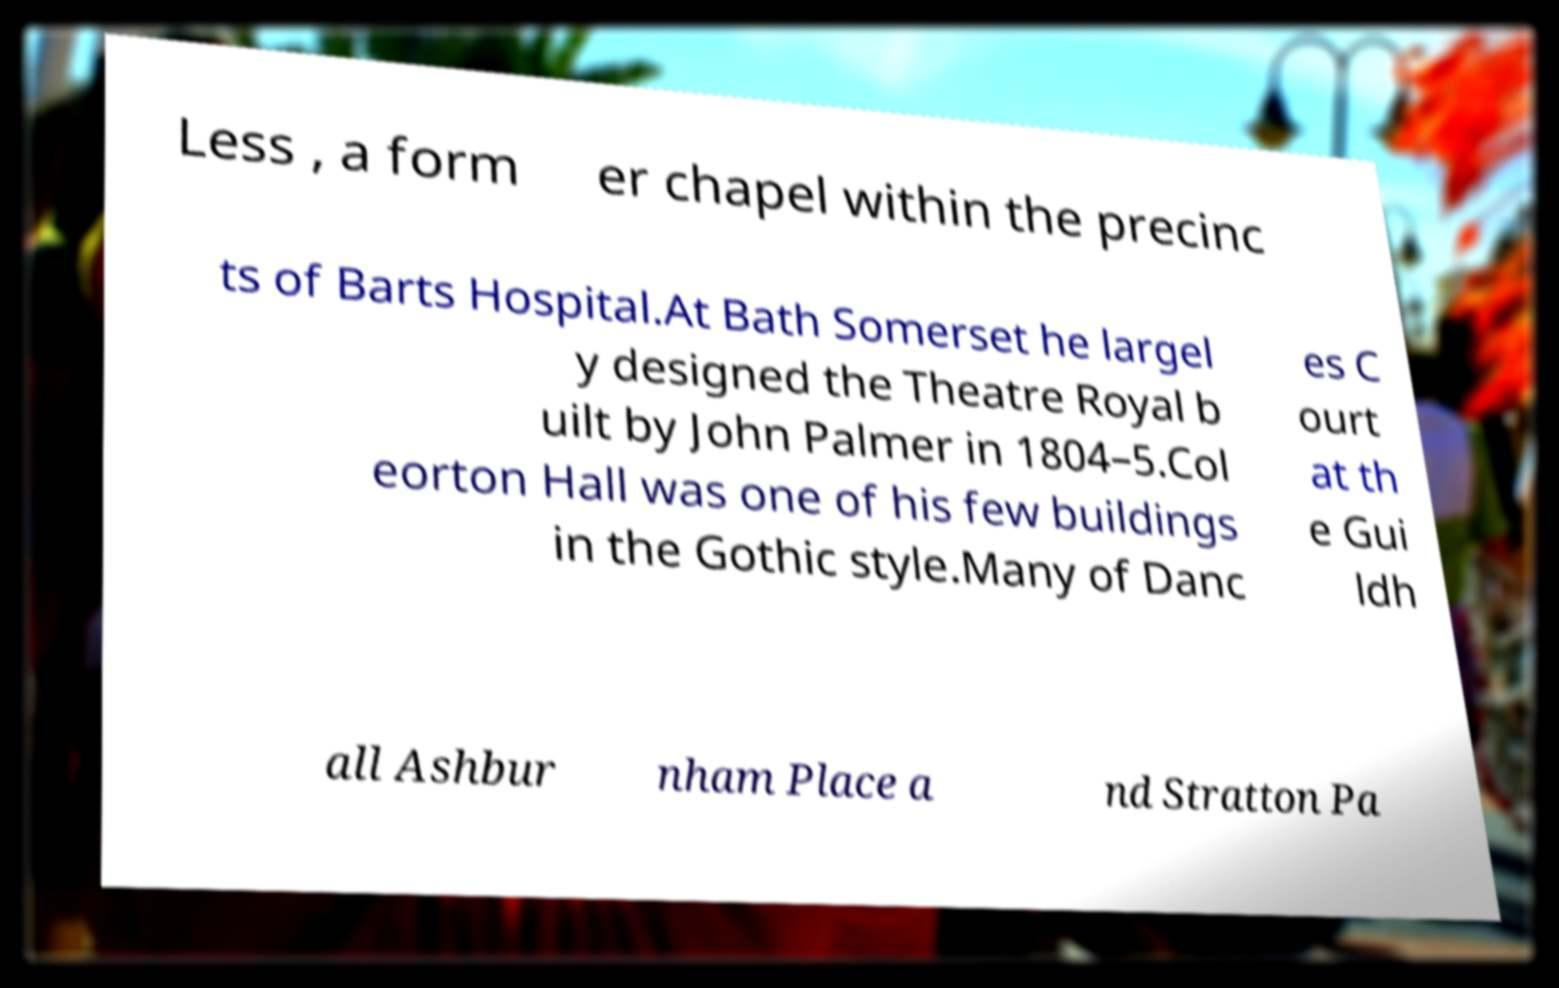I need the written content from this picture converted into text. Can you do that? Less , a form er chapel within the precinc ts of Barts Hospital.At Bath Somerset he largel y designed the Theatre Royal b uilt by John Palmer in 1804–5.Col eorton Hall was one of his few buildings in the Gothic style.Many of Danc es C ourt at th e Gui ldh all Ashbur nham Place a nd Stratton Pa 